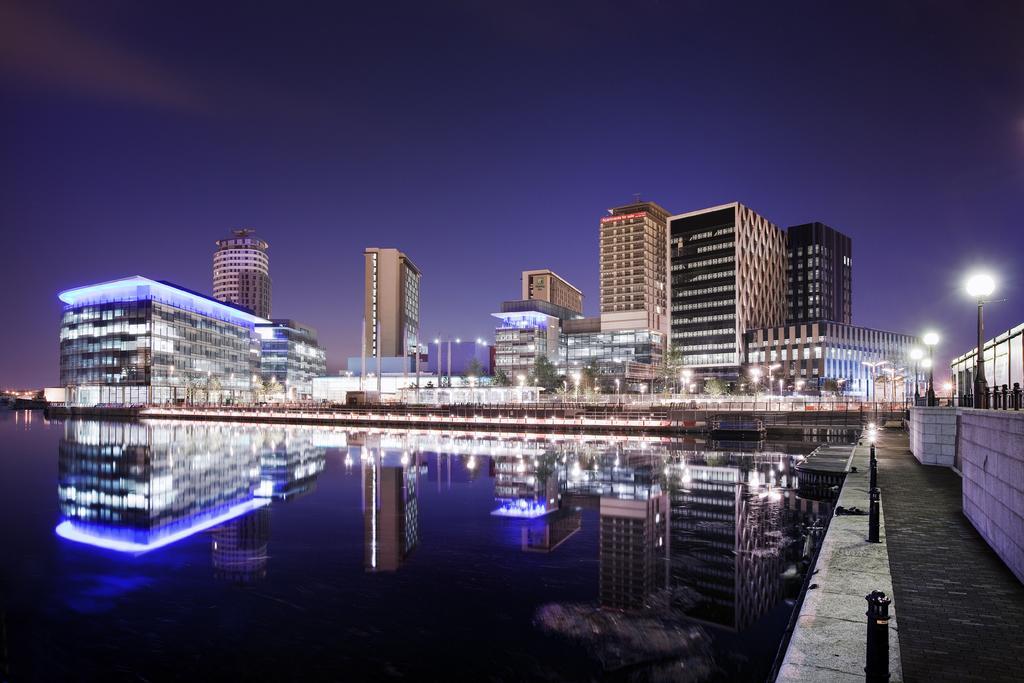How would you summarize this image in a sentence or two? In this image I can see water in the front and on the right side I can see few poles and few lights. In the background I can see number of buildings, few trees, few more lights and few poles. 